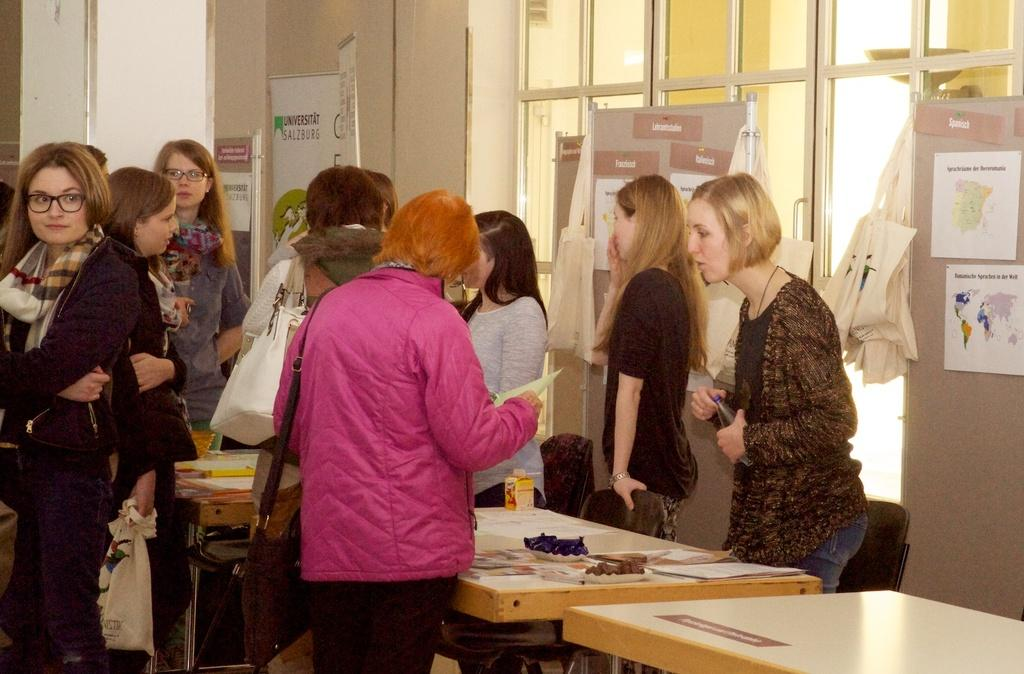How many people are in the image? There is a group of people in the image, but the exact number cannot be determined from the provided facts. What are the people doing in the image? The people are standing in front of a table. What can be seen on the table in the image? There are objects on the table. How many dolls are sitting on the table in the image? There is no mention of dolls in the provided facts, so we cannot determine if any dolls are present in the image. 